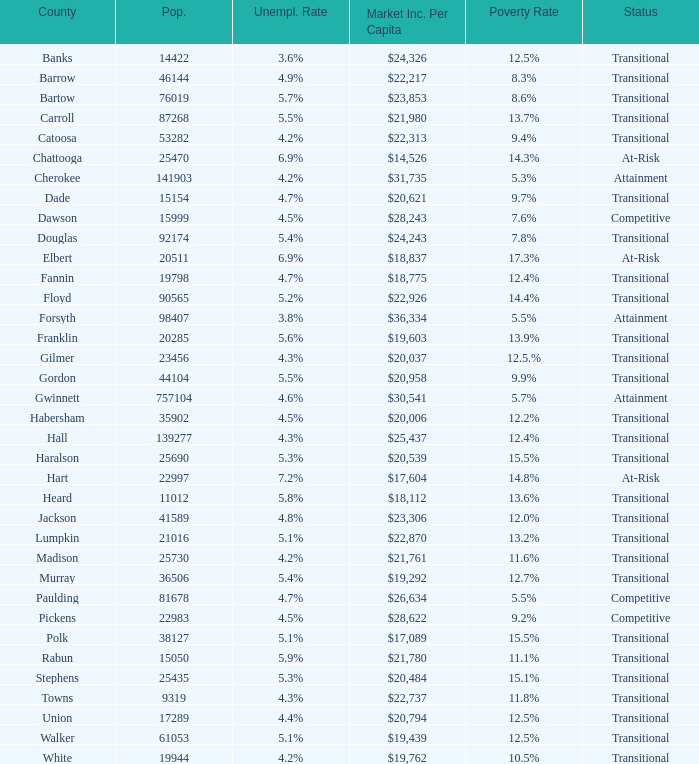What is the number of statuses with a population of 90,565? 1.0. 